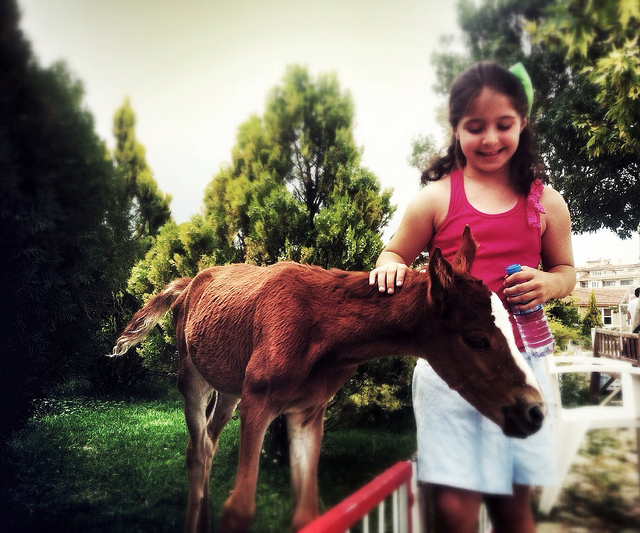<image>What is the name of the marking on the horse's face? I don't know what the name of the marking on the horse's face is. It can be a stripe, blaze, patch or even mane. What is the name of the marking on the horse's face? I don't know the exact name of the marking on the horse's face. It could be referred to as 'coloring', 'mane', 'blaze', 'stripe', or 'patch'. 